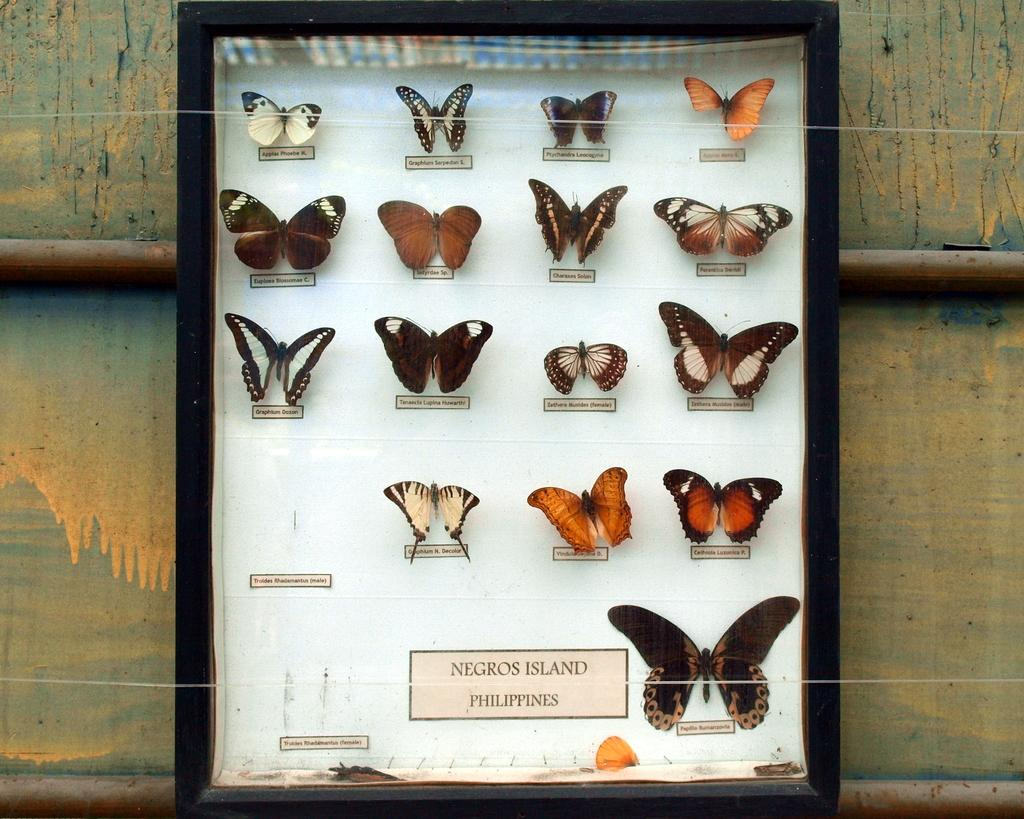What is inside the glass box in the image? There are butterflies in a glass box in the image. Do the butterflies have any specific names? Yes, the butterflies have names. What can be seen in the background of the image? There are iron rods and a wall in the background of the image. What type of fruit is hanging from the iron rods in the image? There is no fruit hanging from the iron rods in the image; they are simply structural elements in the background. 